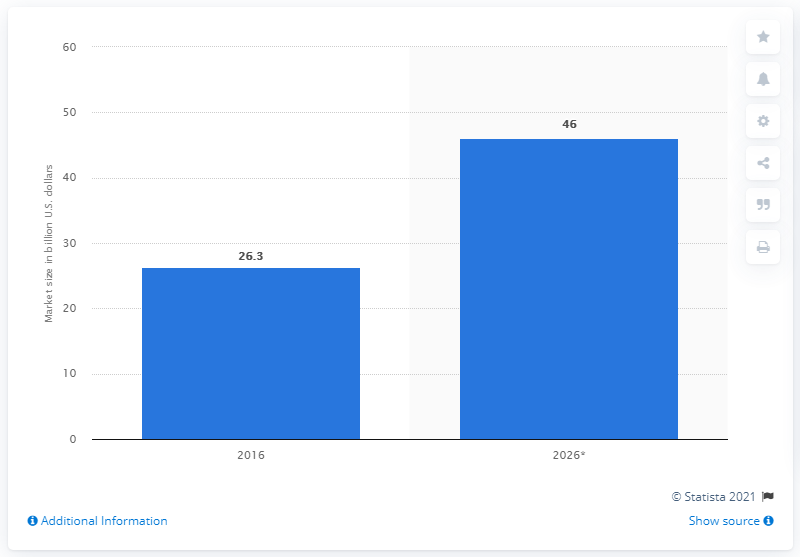Highlight a few significant elements in this photo. By 2026, the market for X is expected to grow to approximately 46.. 